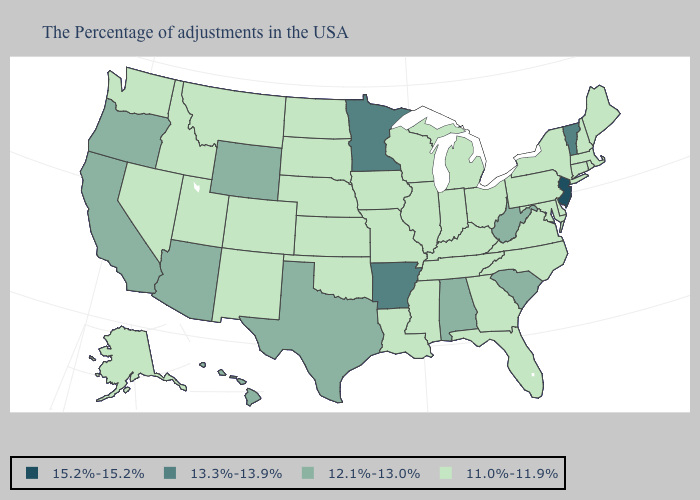What is the value of South Carolina?
Short answer required. 12.1%-13.0%. Which states hav the highest value in the MidWest?
Quick response, please. Minnesota. Does Maryland have the lowest value in the USA?
Concise answer only. Yes. What is the lowest value in the Northeast?
Answer briefly. 11.0%-11.9%. What is the lowest value in the MidWest?
Quick response, please. 11.0%-11.9%. What is the value of Idaho?
Quick response, please. 11.0%-11.9%. Does Mississippi have a lower value than Washington?
Write a very short answer. No. Name the states that have a value in the range 13.3%-13.9%?
Short answer required. Vermont, Arkansas, Minnesota. What is the value of Iowa?
Be succinct. 11.0%-11.9%. What is the value of Rhode Island?
Give a very brief answer. 11.0%-11.9%. What is the lowest value in states that border Mississippi?
Be succinct. 11.0%-11.9%. What is the lowest value in states that border Idaho?
Quick response, please. 11.0%-11.9%. Is the legend a continuous bar?
Give a very brief answer. No. Name the states that have a value in the range 12.1%-13.0%?
Short answer required. South Carolina, West Virginia, Alabama, Texas, Wyoming, Arizona, California, Oregon, Hawaii. What is the value of Mississippi?
Give a very brief answer. 11.0%-11.9%. 